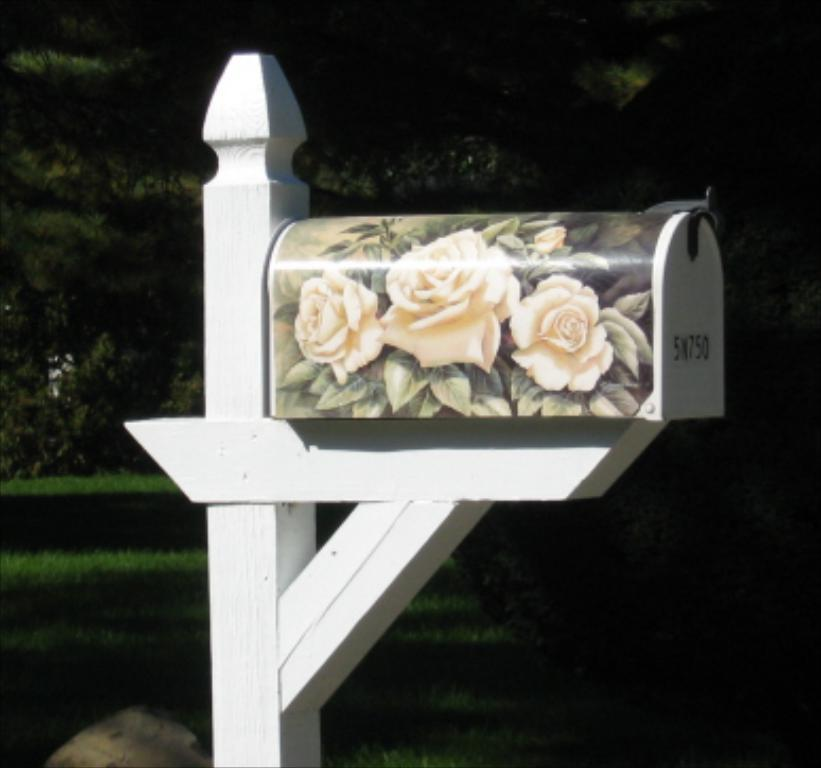What object is the main focus of the image? There is a wooden box in the image. What is on the wooden box? The wooden box has a flowers poster on it. Where is the wooden box placed? The wooden box is on a wooden platform. What can be seen in the background of the image? There are trees and grass in the background of the image. How many brothers are riding the bike in the image? There is no bike or brothers present in the image; it features a wooden box with a flowers poster on it. What type of spoon is being used to stir the grass in the image? There is no spoon or stirring activity in the image; it only shows a wooden box, a flowers poster, and a background with trees and grass. 